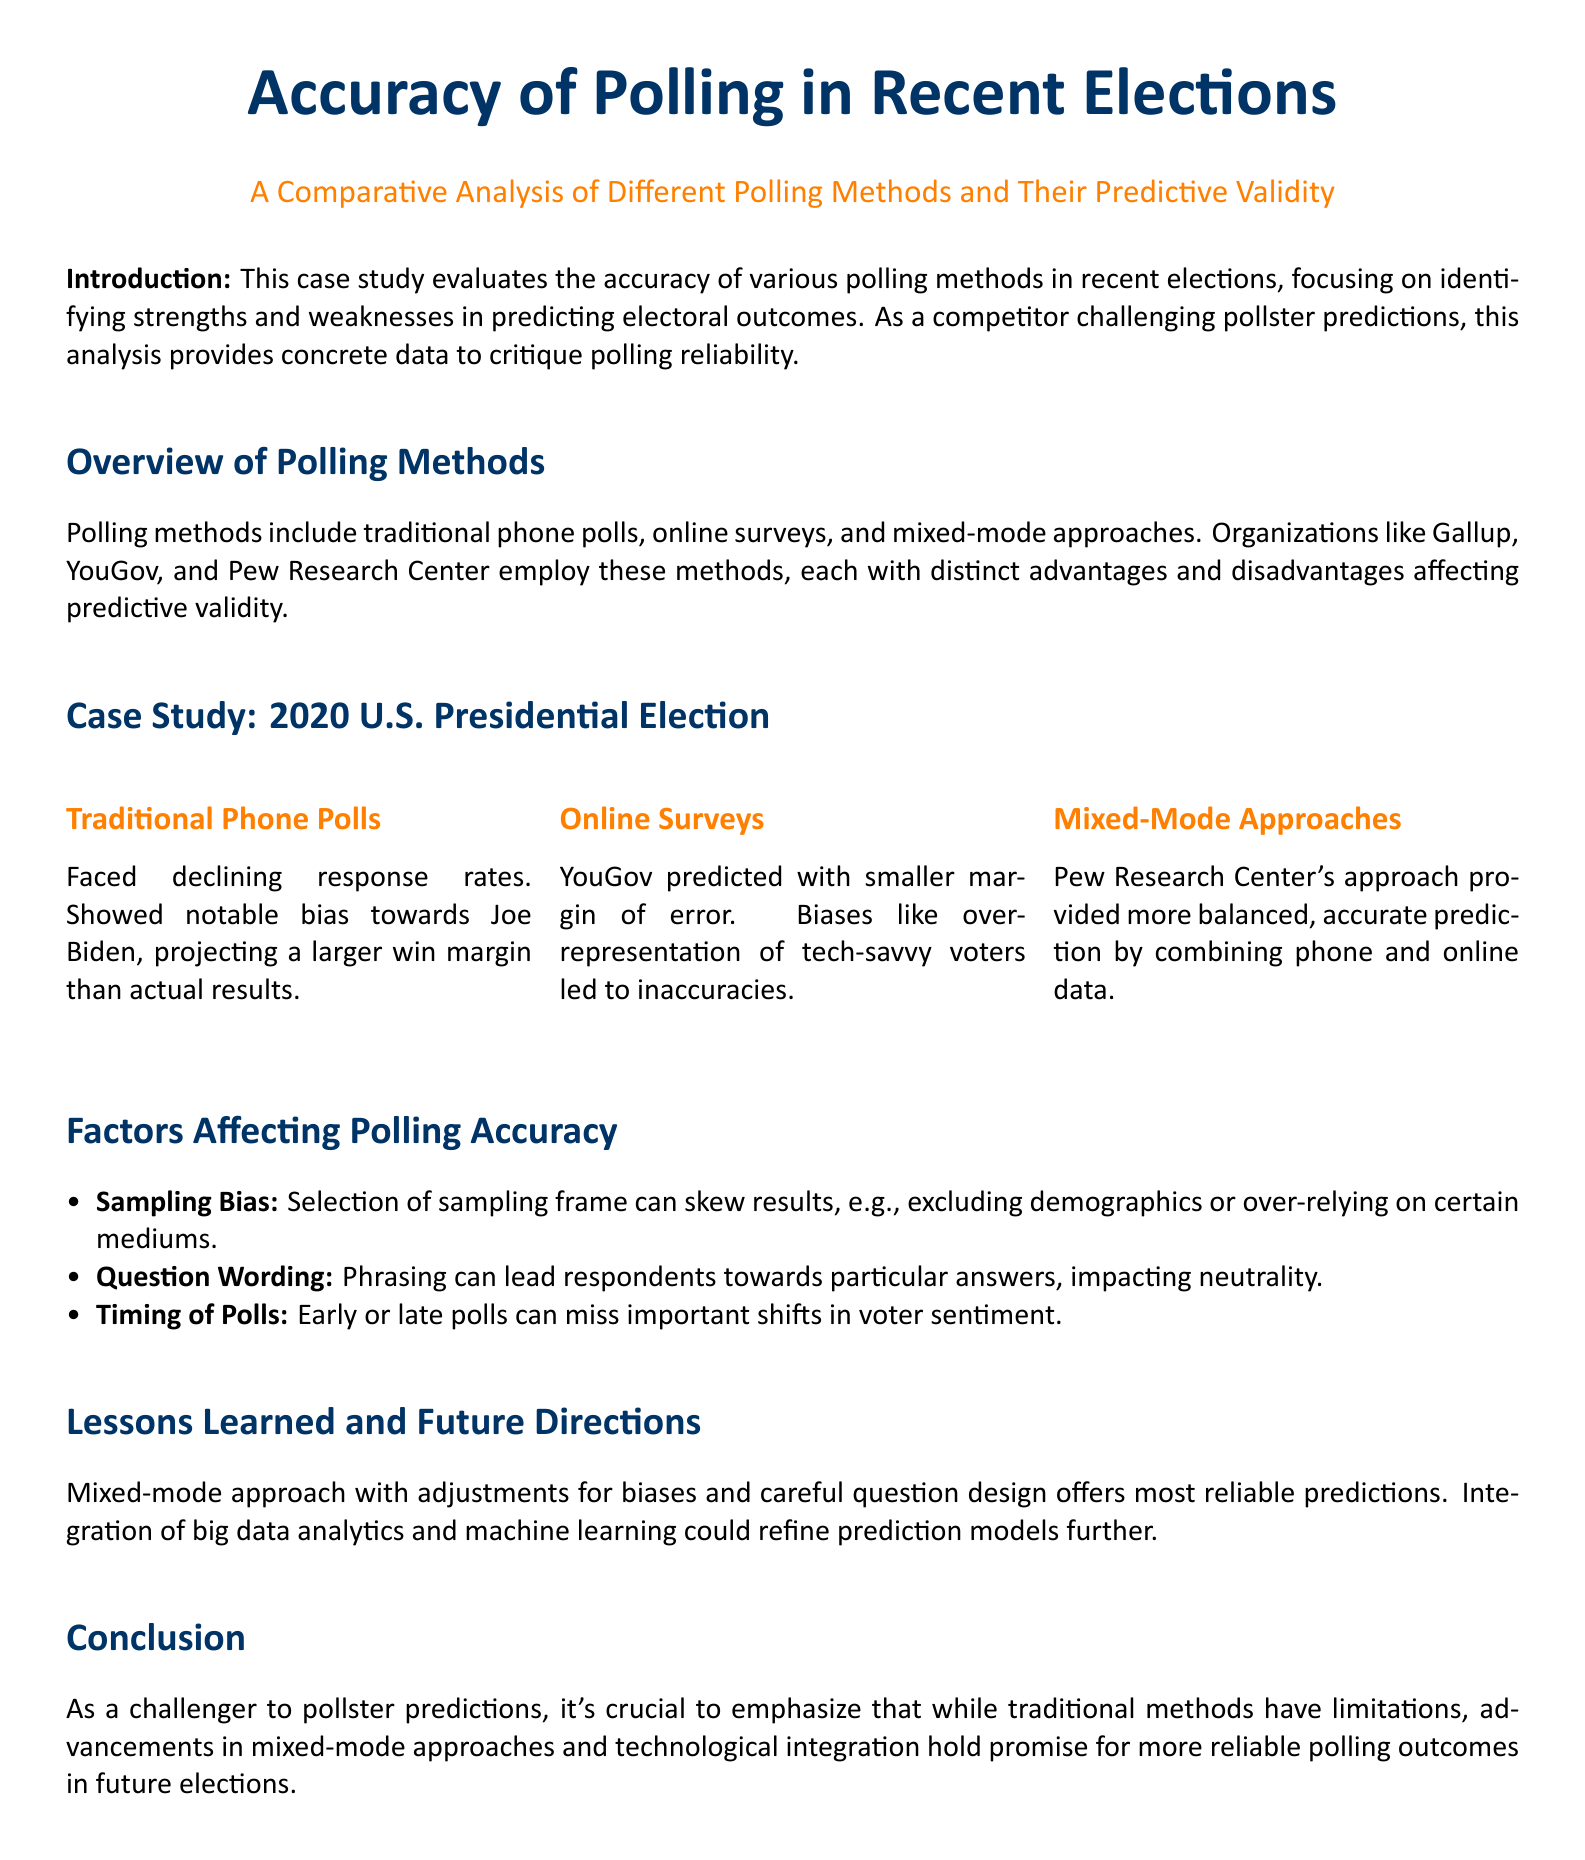what is the title of the case study? The title of the case study is provided in the header, highlighting the focus on polling accuracy in elections.
Answer: Accuracy of Polling in Recent Elections which polling methods are evaluated in the case study? The polling methods discussed include traditional phone polls, online surveys, and mixed-mode approaches.
Answer: Traditional phone polls, online surveys, mixed-mode approaches who predicted with a smaller margin of error in the 2020 U.S. Presidential Election? YouGov is mentioned as having predicted with a smaller margin of error during the election.
Answer: YouGov what major bias was noted in traditional phone polls? The bias noted was that traditional phone polls showed a notable bias towards Joe Biden.
Answer: bias towards Joe Biden what is the main lesson learned regarding polling accuracy? The document states that a mixed-mode approach with adjustments for biases offers the most reliable predictions.
Answer: Mixed-mode approach with adjustments for biases which organization combined phone and online data for improved accuracy? The Pew Research Center is identified as implementing a mixed-mode approach for accuracy.
Answer: Pew Research Center what factor can skew polling results due to the sampling frame? The factor affecting polling accuracy mentioned is “Sampling Bias.”
Answer: Sampling Bias what technological advancements are suggested for future polling improvements? The document suggests the integration of big data analytics and machine learning for improving polling accuracy.
Answer: big data analytics and machine learning 